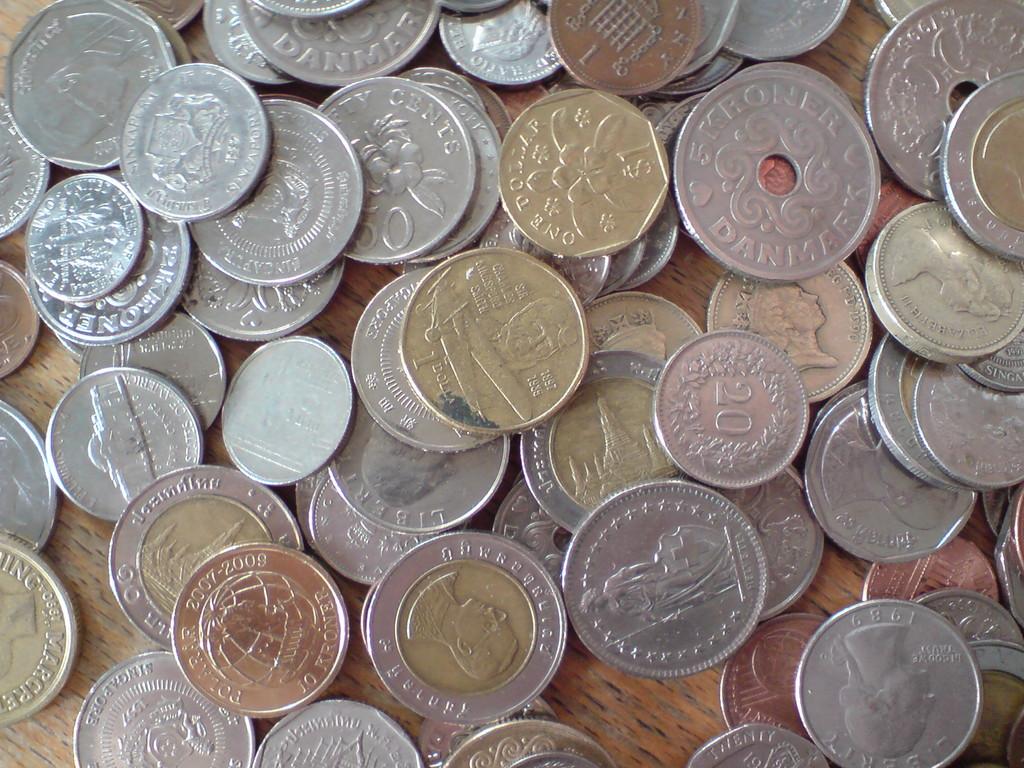Is there a 20 cent piece in this image of coins?
Ensure brevity in your answer.  Yes. Where are these coins from?
Make the answer very short. Denmark. 